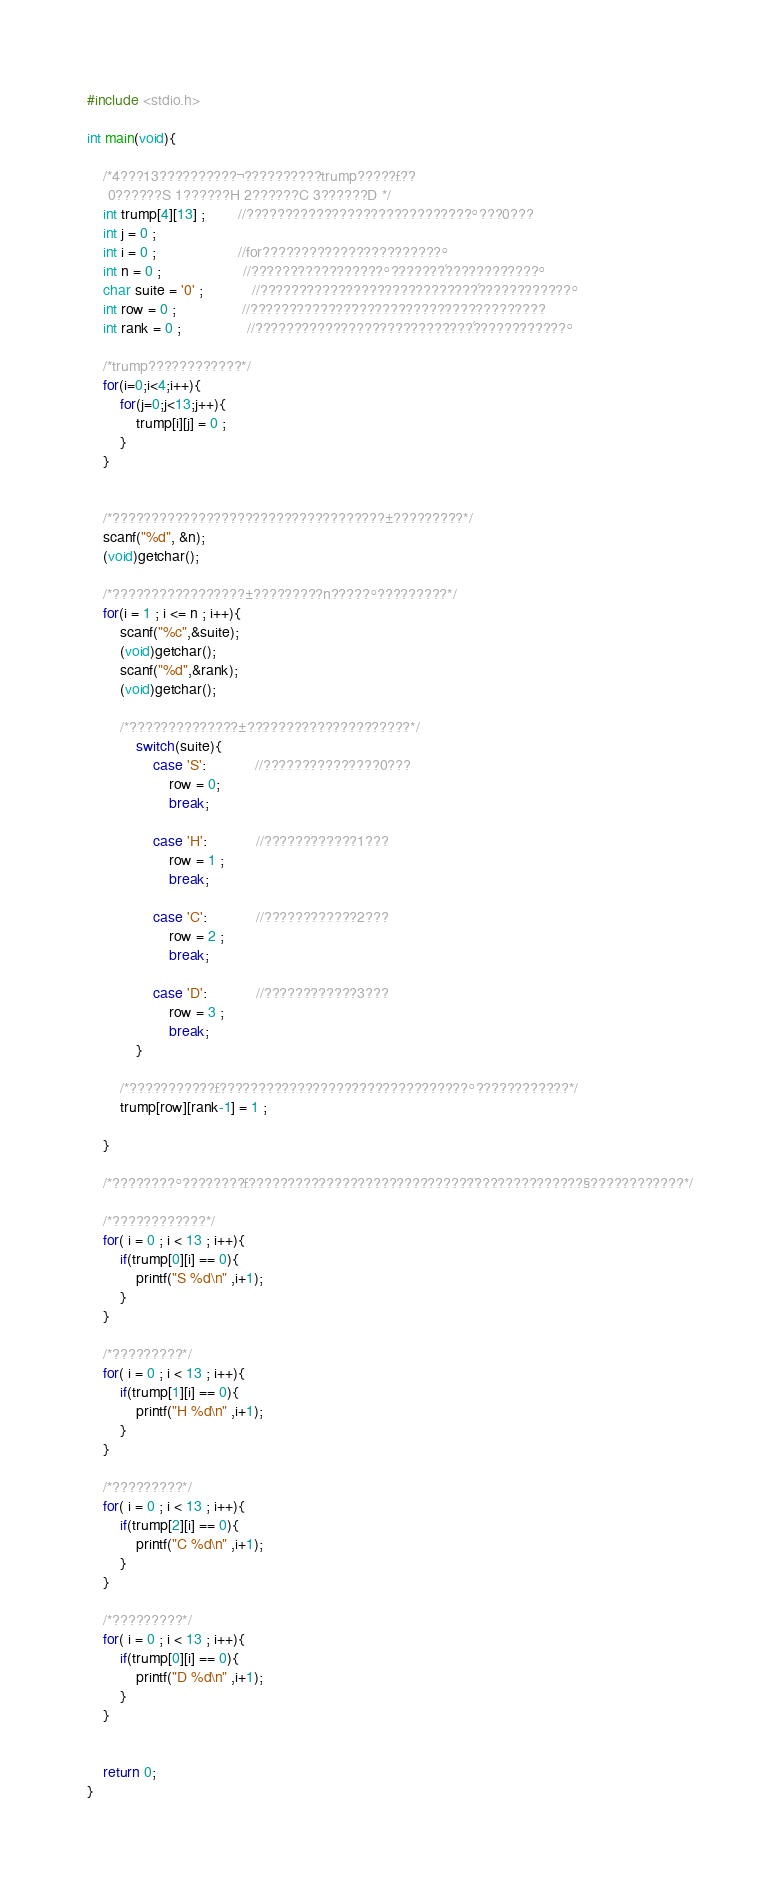Convert code to text. <code><loc_0><loc_0><loc_500><loc_500><_C_>#include <stdio.h>

int main(void){

	/*4???13??????????¬??????????trump?????£?¨?
	 0??????S 1??????H 2??????C 3??????D */
	int trump[4][13] ;		//?????????????????????????????°???0???
	int j = 0 ;
	int i = 0 ;					//for???????????????????????°
	int n = 0 ;					//?????????????????°???????´????????????°
	char suite = '0' ;			//????????????????????????????´????????????°
	int row = 0 ;				//?????????????¨?????????????????????????
	int rank = 0 ;				//????????????????????????????´????????????°

	/*trump????????????*/
	for(i=0;i<4;i++){
		for(j=0;j<13;j++){
			trump[i][j] = 0 ;
		}
	}


	/*???????????????????????????????????±?????????*/
	scanf("%d", &n);
	(void)getchar();

	/*?????????????????±?????????n?????°?????????*/
	for(i = 1 ; i <= n ; i++){
		scanf("%c",&suite);
		(void)getchar();
		scanf("%d",&rank);
		(void)getchar();

		/*??????????????±?????????????????????*/
			switch(suite){
				case 'S':			//???????????????0???
					row = 0;
					break;

				case 'H':			//????????????1???
					row = 1 ;
					break;

				case 'C':			//????????????2???
					row = 2 ;
					break;

				case 'D':			//????????????3???
					row = 3 ;
					break;
			}

		/*???????????£????????????????????????????????°????????????*/
		trump[row][rank-1] = 1 ;

	}

	/*????????°????????£?????????????????????????????¨??????????????§????????????*/

	/*????????????*/
	for( i = 0 ; i < 13 ; i++){
		if(trump[0][i] == 0){
			printf("S %d\n" ,i+1);
		}
	}

	/*?????????*/
	for( i = 0 ; i < 13 ; i++){
		if(trump[1][i] == 0){
			printf("H %d\n" ,i+1);
		}
	}

	/*?????????*/
	for( i = 0 ; i < 13 ; i++){
		if(trump[2][i] == 0){
			printf("C %d\n" ,i+1);
		}
	}

	/*?????????*/
	for( i = 0 ; i < 13 ; i++){
		if(trump[0][i] == 0){
			printf("D %d\n" ,i+1);
		}
	}


	return 0;
}</code> 